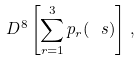Convert formula to latex. <formula><loc_0><loc_0><loc_500><loc_500>\ D ^ { 8 } \left [ \sum _ { r = 1 } ^ { 3 } p _ { r } ( \ s ) \right ] \, ,</formula> 